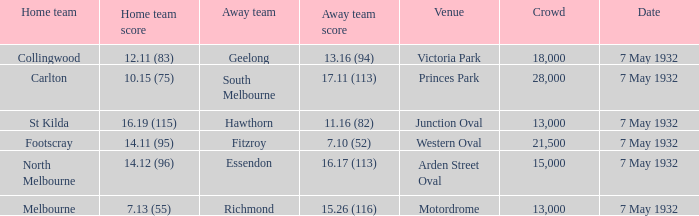Identify the away team that has more than 13,000 spectators and a home team score of 12.11 (83). Geelong. 